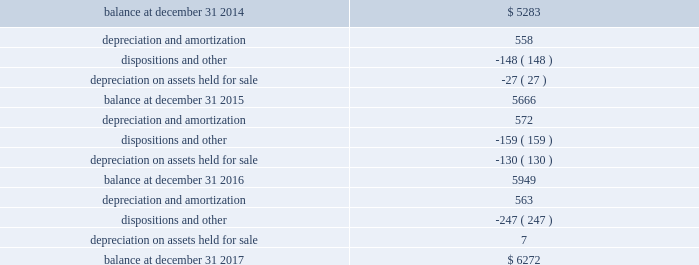Schedule iii page 6 of 6 host hotels & resorts , inc. , and subsidiaries host hotels & resorts , l.p. , and subsidiaries real estate and accumulated depreciation december 31 , 2017 ( in millions ) ( b ) the change in accumulated depreciation and amortization of real estate assets for the fiscal years ended december 31 , 2017 , 2016 and 2015 is as follows: .
( c ) the aggregate cost of real estate for federal income tax purposes is approximately $ 10698 million at december 31 , 2017 .
( d ) the total cost of properties excludes construction-in-progress properties. .
What was the net change in millions in the accumulated depreciation and amortization of real estate assets from 2015 to 2016? 
Computations: (5949 - 5666)
Answer: 283.0. 